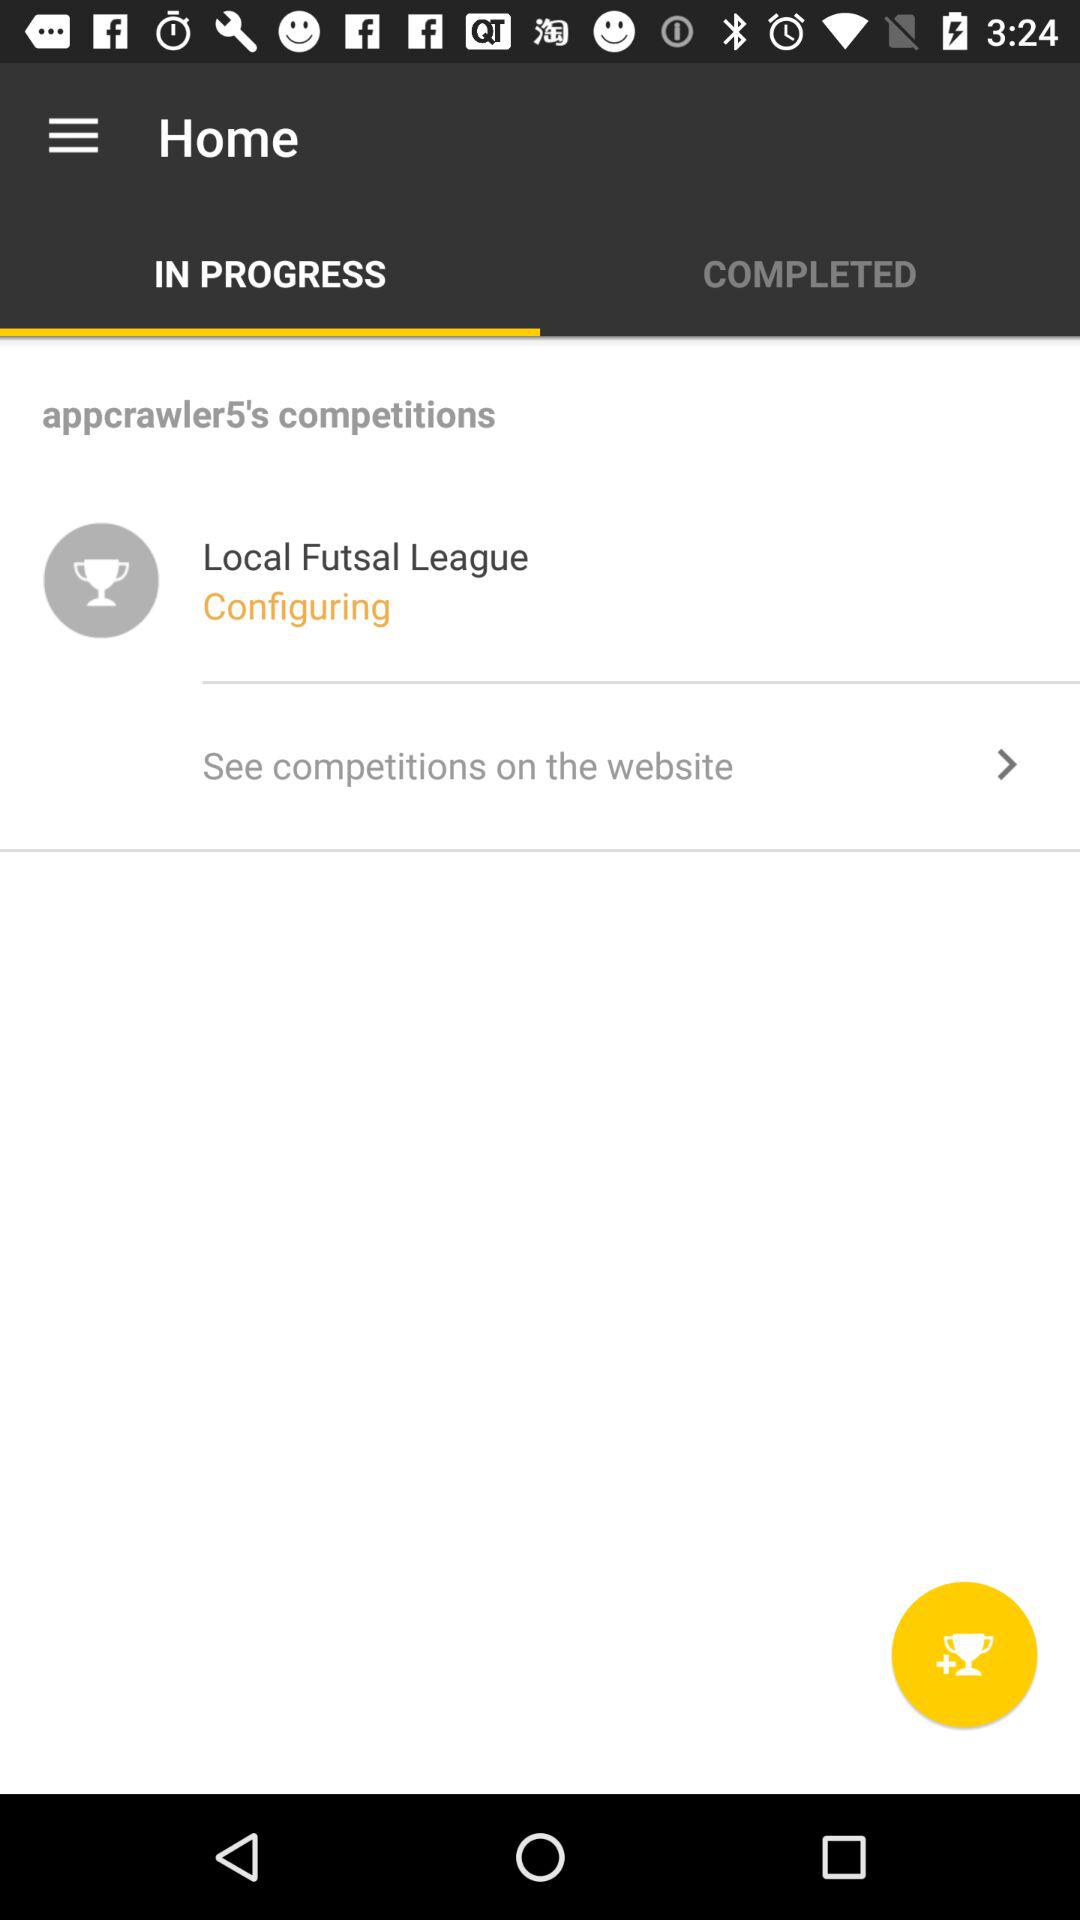What is the league name? The league name is "Local Futsal League". 